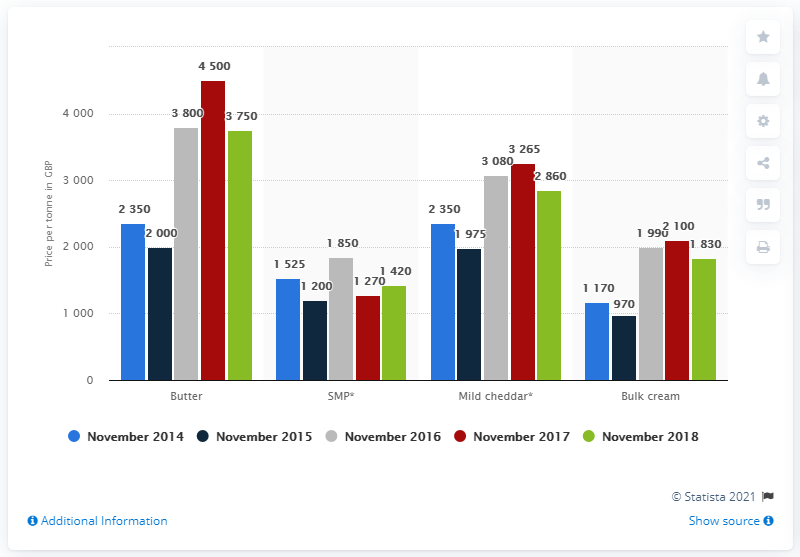Highlight a few significant elements in this photo. As of November 2018, the wholesale price of butter was 3,750. 